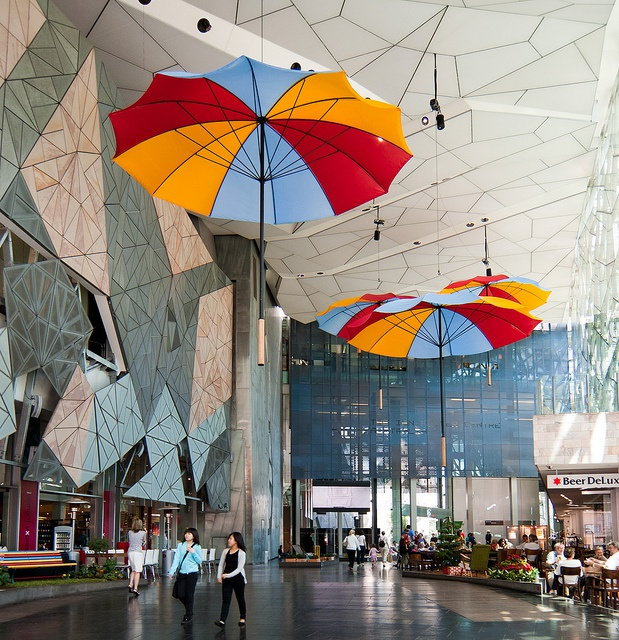Describe the objects in this image and their specific colors. I can see umbrella in tan, orange, brown, lightblue, and darkgray tones, umbrella in tan, orange, brown, and lightblue tones, people in tan, black, gray, lightgray, and darkgray tones, people in tan, black, lightblue, and lightgray tones, and people in tan, black, gray, darkgray, and maroon tones in this image. 